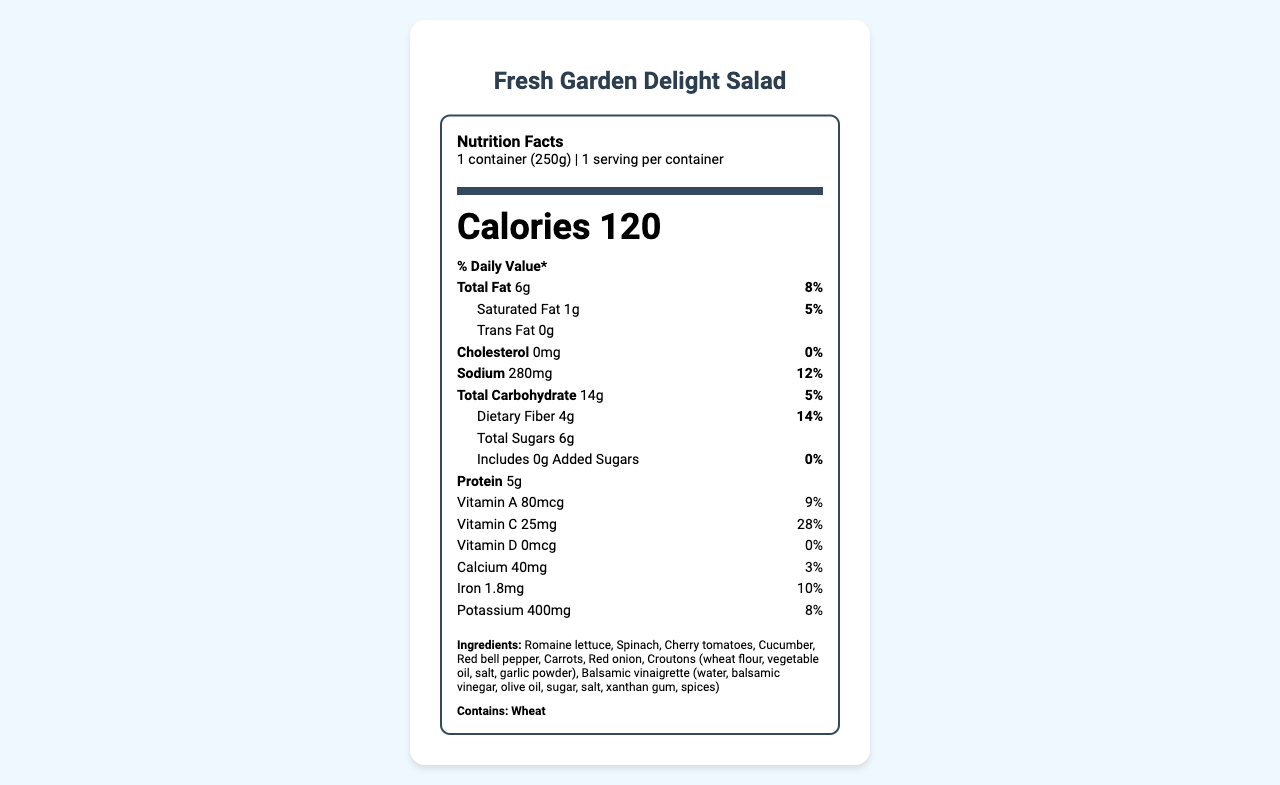what is the serving size of this salad? The serving size is explicitly stated as "1 container (250g)" in the document.
Answer: 1 container (250g) how many calories are in one serving of this salad? The label clearly lists "Calories 120" which refers to the calories per serving.
Answer: 120 what is the percentage daily value of sodium for one serving? The document states that the daily value percentage for sodium is 12%.
Answer: 12% how much cholesterol is in one serving of this salad? The cholesterol amount is stated as 0 mg and its daily value percentage is 0%.
Answer: 0 mg which ingredient in the salad might pose an allergen risk? The allergens section lists "Contains: Wheat".
Answer: Wheat what is the total amount of dietary fiber in one serving? The dietary fiber amount is listed as 4 g with a daily value of 14%.
Answer: 4 g how many grams of protein does one serving of this salad contain? The amount of protein per serving is explicitly listed as 5 g.
Answer: 5 g how much calcium is in this salad and what is its daily value percentage? The calcium amount is 40 mg with a daily value percentage of 3%.
Answer: 40 mg, 3% which ingredients are included in the croutons? The ingredients list specifies the components of the croutons.
Answer: Wheat flour, vegetable oil, salt, garlic powder what are the main ingredients in the balsamic vinaigrette? A. Olive oil, balsamic vinegar, water B. Water, balsamic vinegar, olive oil C. Balsamic vinegar, salt, sugar The balsamic vinaigrette ingredients are listed as water, balsamic vinegar, olive oil, sugar, salt, xanthan gum, and spices.
Answer: B What is the total fat content in one serving and its daily value percentage? A. 5g, 6% B. 6g, 8% C. 7g, 9% The document states that the total fat content is 6g and its daily value percentage is 8%.
Answer: B does this salad contain any added sugars? The label indicates "Includes 0g Added Sugars" with a daily value of 0%.
Answer: No summarize the main nutritional components of this salad. This summary encapsulates the key nutritional values, vitamins, minerals, and ingredients present in the salad.
Answer: The Fresh Garden Delight Salad has 120 calories per serving, 6g of total fat (8% DV), 1g of saturated fat (5% DV), no trans fat or cholesterol, 280mg of sodium (12% DV), 14g total carbohydrates (5% DV) including 4g dietary fiber (14% DV) and 6g total sugars, no added sugars, and 5g of protein. It contains various vitamins and minerals and the main ingredients are a mix of fresh vegetables and croutons with balsamic vinaigrette. how much trans fat is in one serving of this salad? The label indicates there is 0g of trans fat in one serving of the salad.
Answer: 0 g how many servings are in one container? The label specifies that there is 1 serving per container.
Answer: 1 what percentage of the daily value of vitamin C does the salad provide? The document states that the daily value percentage for vitamin C is 28%.
Answer: 28% What are the main ingredients of this salad? The document lists all these items in the ingredients section.
Answer: Romaine lettuce, Spinach, Cherry tomatoes, Cucumber, Red bell pepper, Carrots, Red onion, Croutons, Balsamic vinaigrette how much potassium is in the salad and what is its daily value percentage? The label indicates the salad contains 400 mg of potassium with a daily value of 8%.
Answer: 400 mg, 8% is the nutritional information artifically supplemented? The document does not provide any information regarding artificial supplementation of the nutritional values.
Answer: Not enough information 